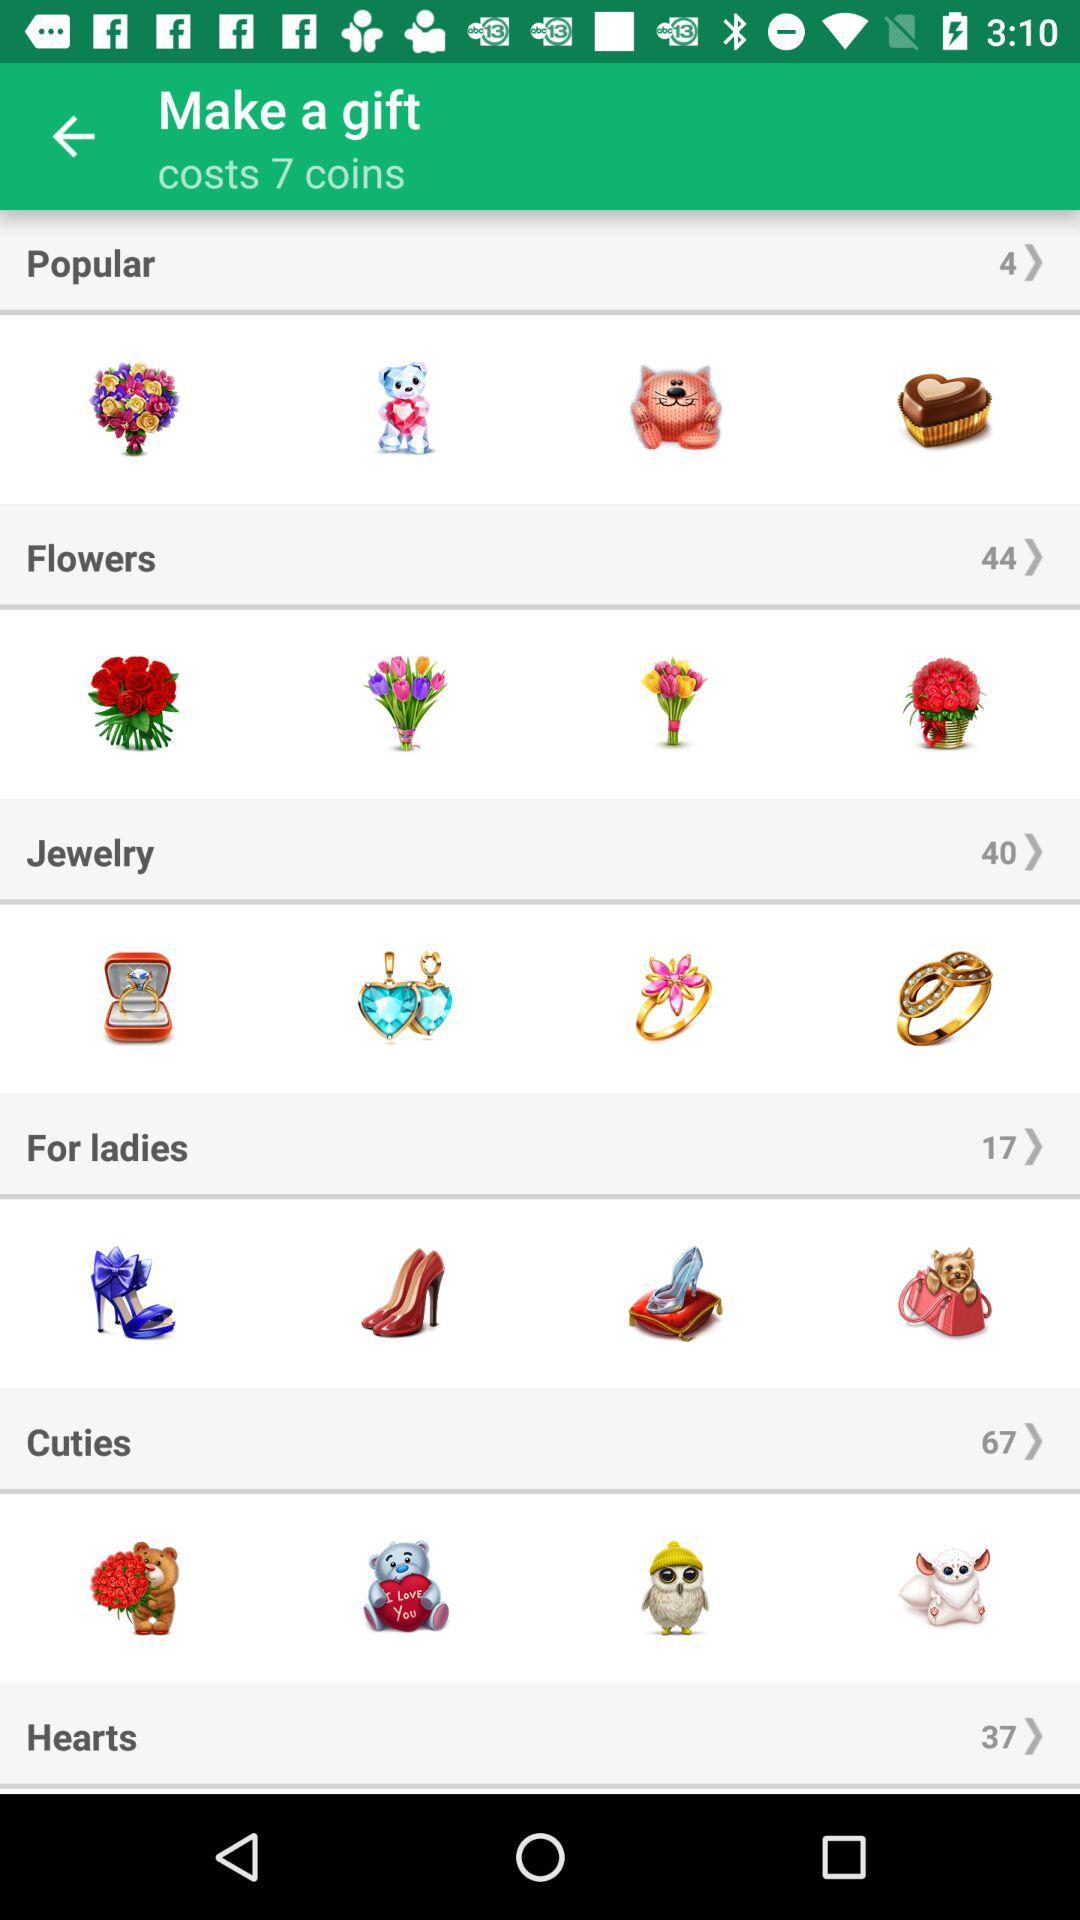How much does it cost to make a gift? It costs 7 coins to make a gift. 